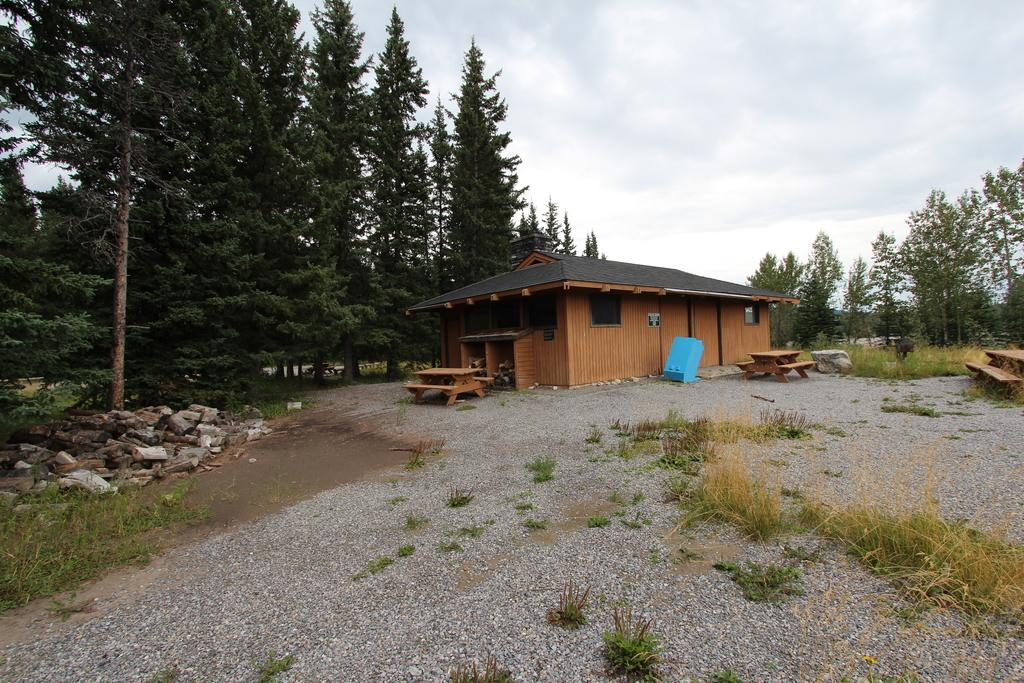What type of area is depicted in the image? The image shows an open area. What kind of structure can be seen in the image? There is a wooden house in the image. What type of seating is available in the open area? There are benches in the image. What can be seen in the background of the image? There are trees and a clear sky in the background of the image. What type of brass instrument is being played in the image? There is no brass instrument or any indication of music being played in the image. 